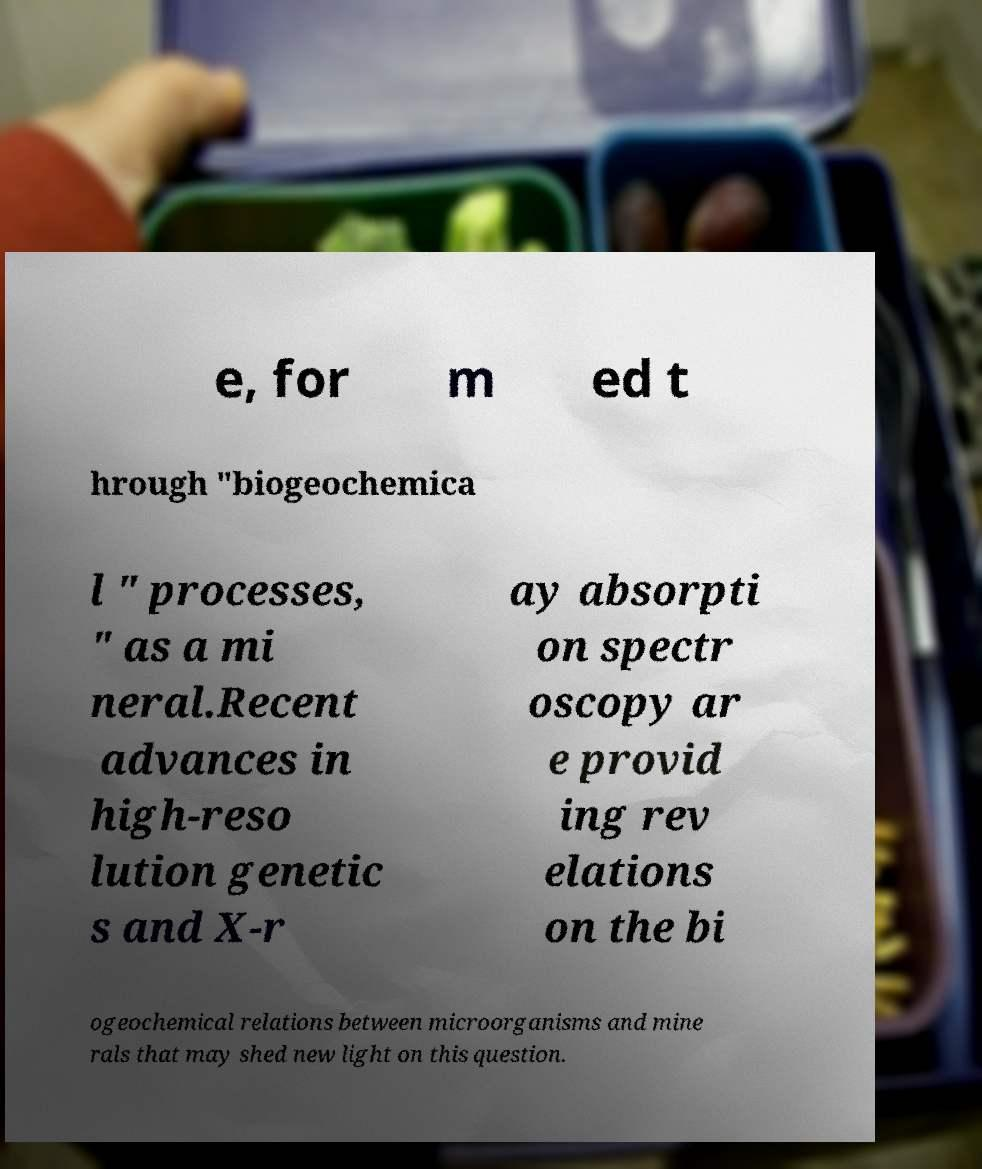What messages or text are displayed in this image? I need them in a readable, typed format. e, for m ed t hrough "biogeochemica l " processes, " as a mi neral.Recent advances in high-reso lution genetic s and X-r ay absorpti on spectr oscopy ar e provid ing rev elations on the bi ogeochemical relations between microorganisms and mine rals that may shed new light on this question. 